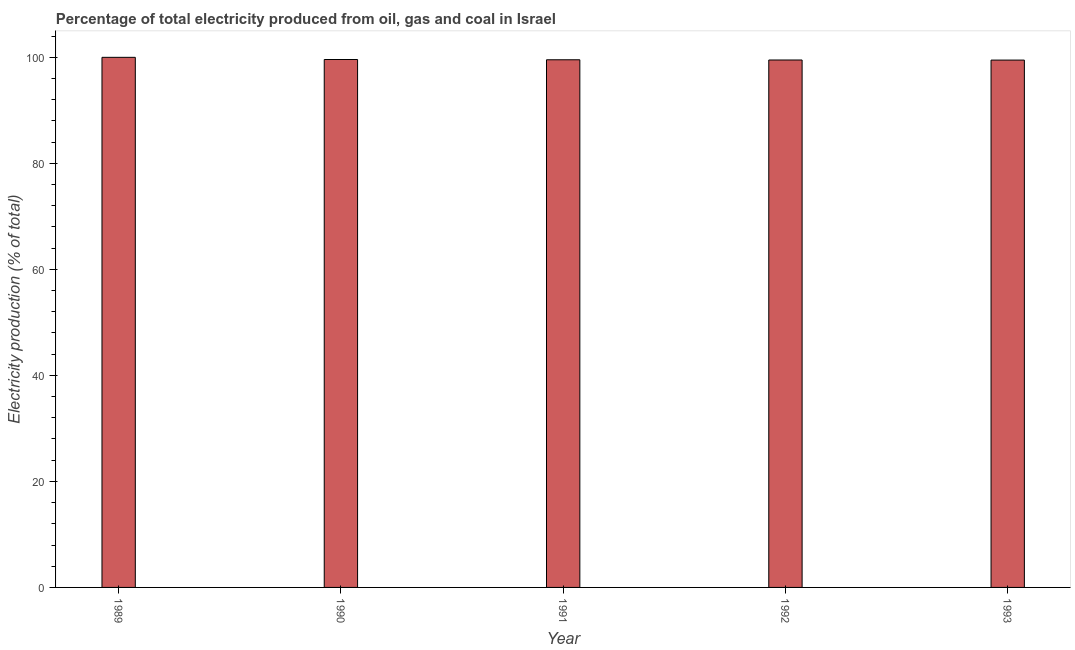Does the graph contain any zero values?
Provide a short and direct response. No. Does the graph contain grids?
Keep it short and to the point. No. What is the title of the graph?
Provide a succinct answer. Percentage of total electricity produced from oil, gas and coal in Israel. What is the label or title of the X-axis?
Your answer should be very brief. Year. What is the label or title of the Y-axis?
Ensure brevity in your answer.  Electricity production (% of total). What is the electricity production in 1992?
Make the answer very short. 99.48. Across all years, what is the maximum electricity production?
Ensure brevity in your answer.  99.99. Across all years, what is the minimum electricity production?
Keep it short and to the point. 99.47. In which year was the electricity production maximum?
Offer a very short reply. 1989. What is the sum of the electricity production?
Your answer should be very brief. 498.03. What is the difference between the electricity production in 1990 and 1992?
Offer a very short reply. 0.09. What is the average electricity production per year?
Make the answer very short. 99.61. What is the median electricity production?
Give a very brief answer. 99.53. In how many years, is the electricity production greater than 12 %?
Your answer should be very brief. 5. What is the ratio of the electricity production in 1992 to that in 1993?
Make the answer very short. 1. Is the electricity production in 1989 less than that in 1993?
Your answer should be very brief. No. Is the difference between the electricity production in 1990 and 1991 greater than the difference between any two years?
Ensure brevity in your answer.  No. What is the difference between the highest and the second highest electricity production?
Offer a very short reply. 0.41. Is the sum of the electricity production in 1991 and 1993 greater than the maximum electricity production across all years?
Your answer should be very brief. Yes. What is the difference between the highest and the lowest electricity production?
Your response must be concise. 0.52. How many years are there in the graph?
Your answer should be compact. 5. What is the Electricity production (% of total) in 1989?
Your answer should be very brief. 99.99. What is the Electricity production (% of total) in 1990?
Keep it short and to the point. 99.57. What is the Electricity production (% of total) of 1991?
Provide a short and direct response. 99.53. What is the Electricity production (% of total) in 1992?
Offer a very short reply. 99.48. What is the Electricity production (% of total) of 1993?
Ensure brevity in your answer.  99.47. What is the difference between the Electricity production (% of total) in 1989 and 1990?
Offer a terse response. 0.41. What is the difference between the Electricity production (% of total) in 1989 and 1991?
Give a very brief answer. 0.46. What is the difference between the Electricity production (% of total) in 1989 and 1992?
Your response must be concise. 0.5. What is the difference between the Electricity production (% of total) in 1989 and 1993?
Your answer should be compact. 0.52. What is the difference between the Electricity production (% of total) in 1990 and 1991?
Your answer should be compact. 0.05. What is the difference between the Electricity production (% of total) in 1990 and 1992?
Provide a short and direct response. 0.09. What is the difference between the Electricity production (% of total) in 1990 and 1993?
Keep it short and to the point. 0.11. What is the difference between the Electricity production (% of total) in 1991 and 1992?
Keep it short and to the point. 0.04. What is the difference between the Electricity production (% of total) in 1991 and 1993?
Offer a terse response. 0.06. What is the difference between the Electricity production (% of total) in 1992 and 1993?
Make the answer very short. 0.02. What is the ratio of the Electricity production (% of total) in 1989 to that in 1991?
Provide a short and direct response. 1. What is the ratio of the Electricity production (% of total) in 1989 to that in 1992?
Ensure brevity in your answer.  1. What is the ratio of the Electricity production (% of total) in 1990 to that in 1992?
Offer a very short reply. 1. What is the ratio of the Electricity production (% of total) in 1991 to that in 1993?
Make the answer very short. 1. What is the ratio of the Electricity production (% of total) in 1992 to that in 1993?
Offer a terse response. 1. 